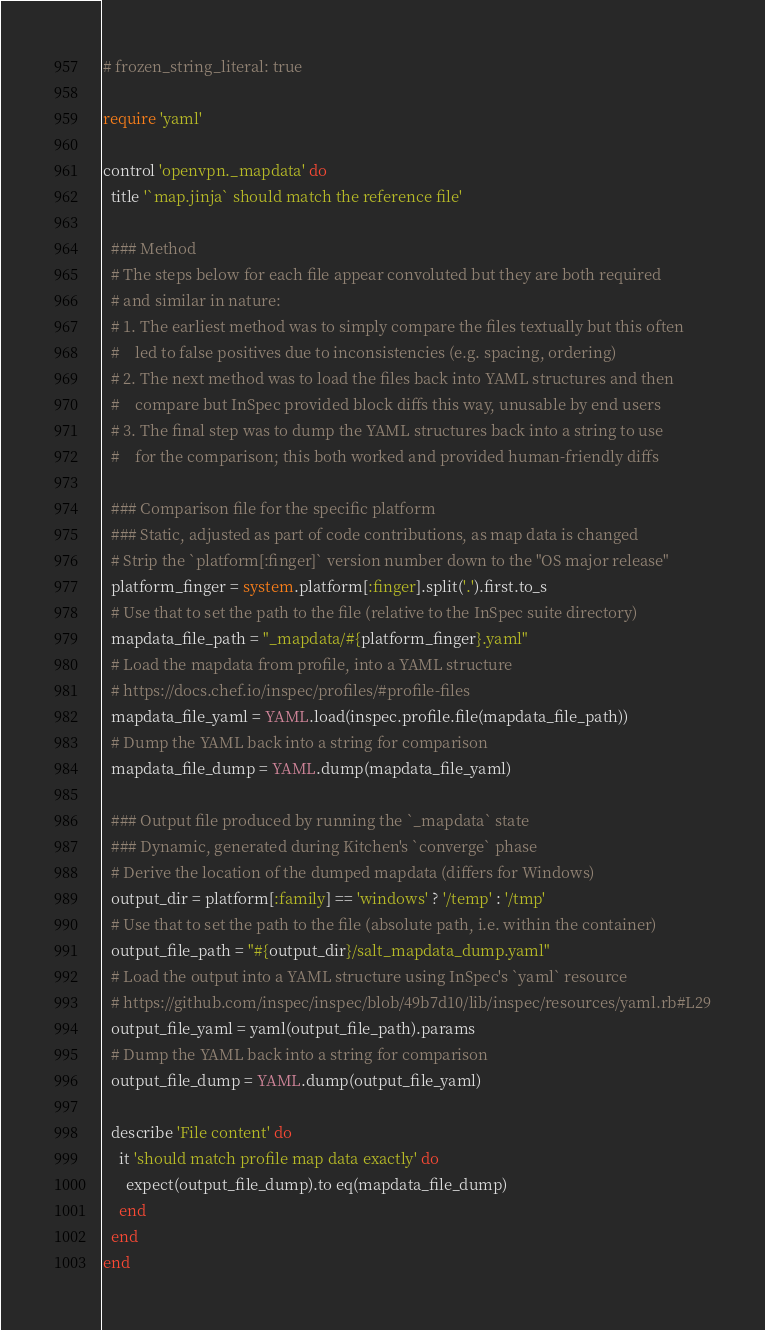Convert code to text. <code><loc_0><loc_0><loc_500><loc_500><_Ruby_># frozen_string_literal: true

require 'yaml'

control 'openvpn._mapdata' do
  title '`map.jinja` should match the reference file'

  ### Method
  # The steps below for each file appear convoluted but they are both required
  # and similar in nature:
  # 1. The earliest method was to simply compare the files textually but this often
  #    led to false positives due to inconsistencies (e.g. spacing, ordering)
  # 2. The next method was to load the files back into YAML structures and then
  #    compare but InSpec provided block diffs this way, unusable by end users
  # 3. The final step was to dump the YAML structures back into a string to use
  #    for the comparison; this both worked and provided human-friendly diffs

  ### Comparison file for the specific platform
  ### Static, adjusted as part of code contributions, as map data is changed
  # Strip the `platform[:finger]` version number down to the "OS major release"
  platform_finger = system.platform[:finger].split('.').first.to_s
  # Use that to set the path to the file (relative to the InSpec suite directory)
  mapdata_file_path = "_mapdata/#{platform_finger}.yaml"
  # Load the mapdata from profile, into a YAML structure
  # https://docs.chef.io/inspec/profiles/#profile-files
  mapdata_file_yaml = YAML.load(inspec.profile.file(mapdata_file_path))
  # Dump the YAML back into a string for comparison
  mapdata_file_dump = YAML.dump(mapdata_file_yaml)

  ### Output file produced by running the `_mapdata` state
  ### Dynamic, generated during Kitchen's `converge` phase
  # Derive the location of the dumped mapdata (differs for Windows)
  output_dir = platform[:family] == 'windows' ? '/temp' : '/tmp'
  # Use that to set the path to the file (absolute path, i.e. within the container)
  output_file_path = "#{output_dir}/salt_mapdata_dump.yaml"
  # Load the output into a YAML structure using InSpec's `yaml` resource
  # https://github.com/inspec/inspec/blob/49b7d10/lib/inspec/resources/yaml.rb#L29
  output_file_yaml = yaml(output_file_path).params
  # Dump the YAML back into a string for comparison
  output_file_dump = YAML.dump(output_file_yaml)

  describe 'File content' do
    it 'should match profile map data exactly' do
      expect(output_file_dump).to eq(mapdata_file_dump)
    end
  end
end
</code> 